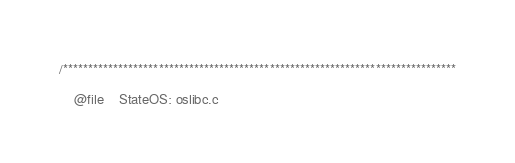<code> <loc_0><loc_0><loc_500><loc_500><_C_>/******************************************************************************

    @file    StateOS: oslibc.c</code> 